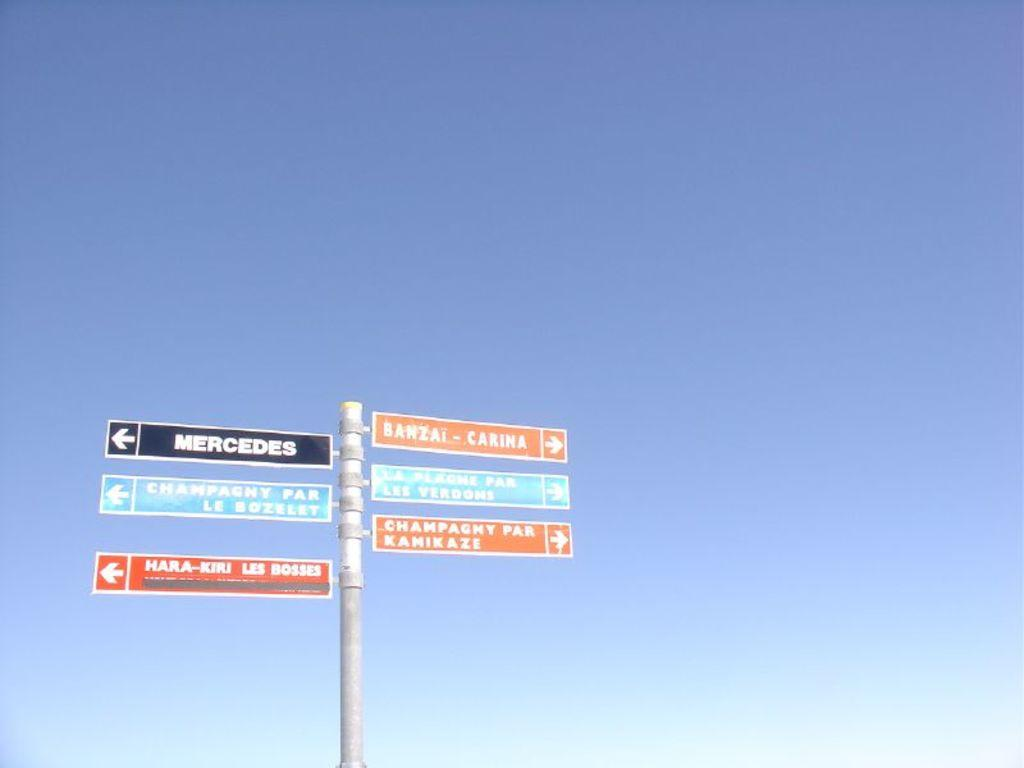<image>
Offer a succinct explanation of the picture presented. Many signs on a pole including one that says MERCEDES. 